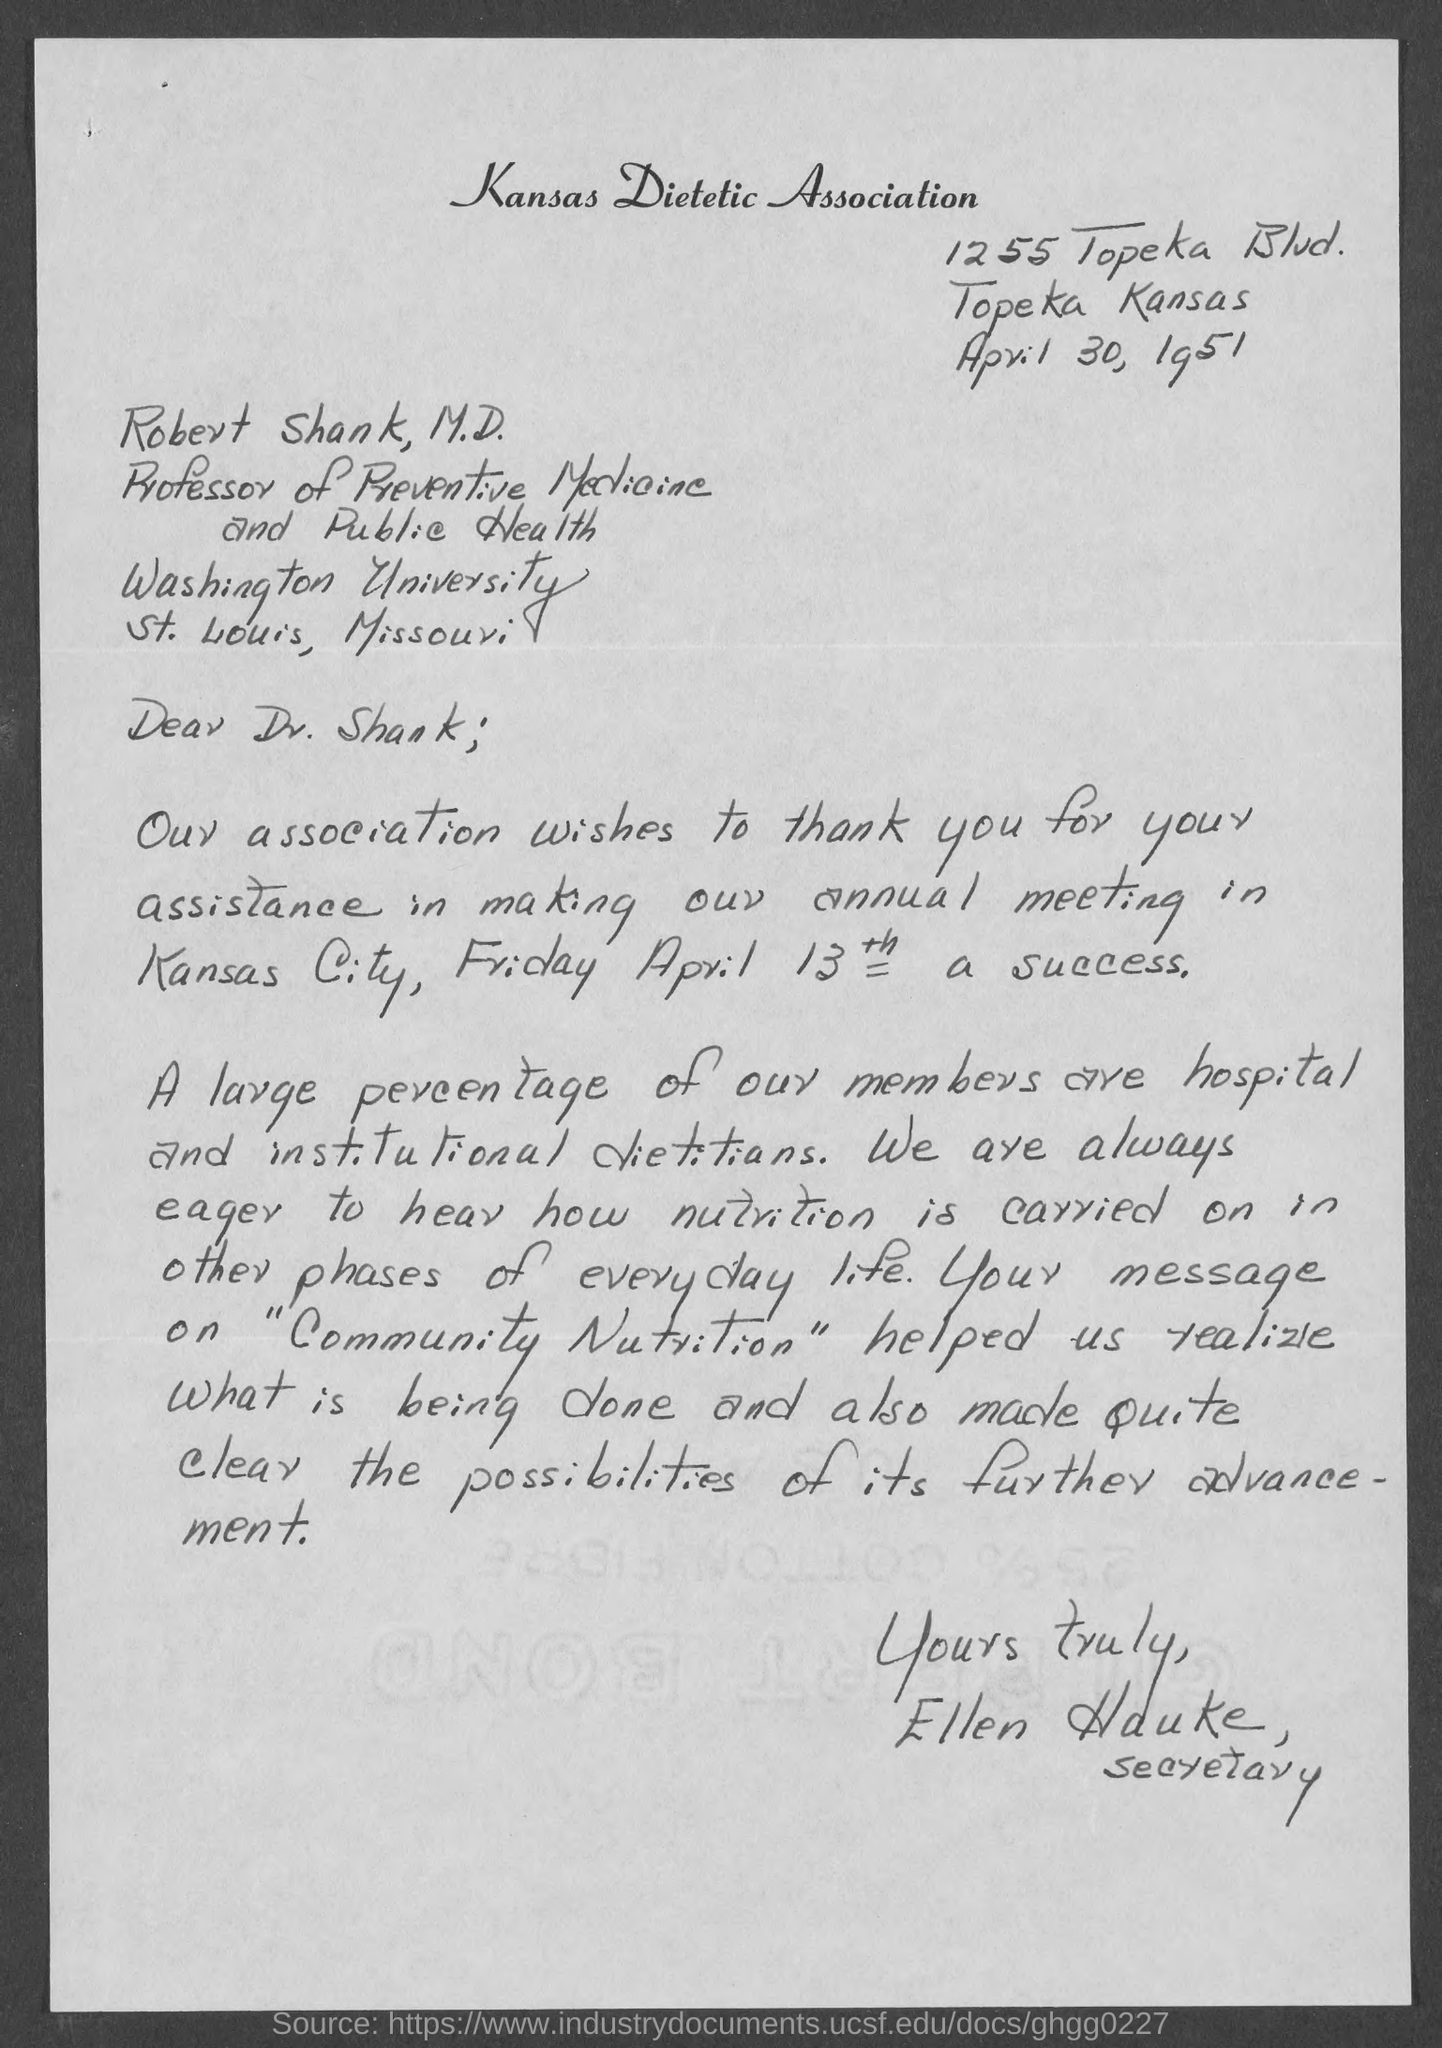Give some essential details in this illustration. Robert Shank is a Professor of Preventive Medicine and Public Health. Ellen Hauke is a secretary. The Kansas Dietetic Association is mentioned. The letter is dated April 30, 1951. The letter is addressed to Robert Shank, M.D. 